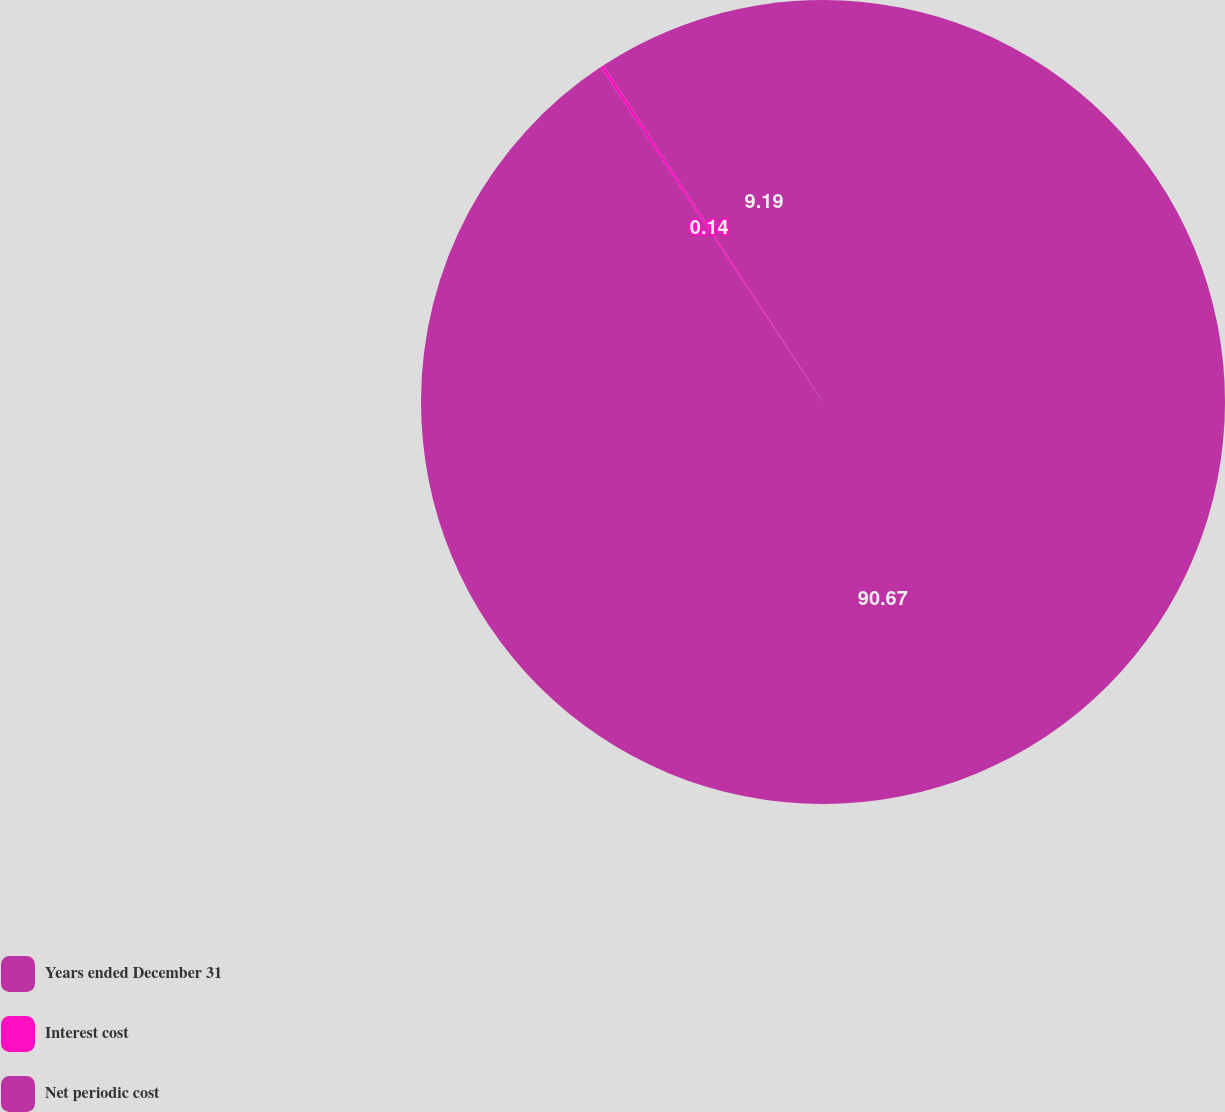Convert chart. <chart><loc_0><loc_0><loc_500><loc_500><pie_chart><fcel>Years ended December 31<fcel>Interest cost<fcel>Net periodic cost<nl><fcel>90.67%<fcel>0.14%<fcel>9.19%<nl></chart> 